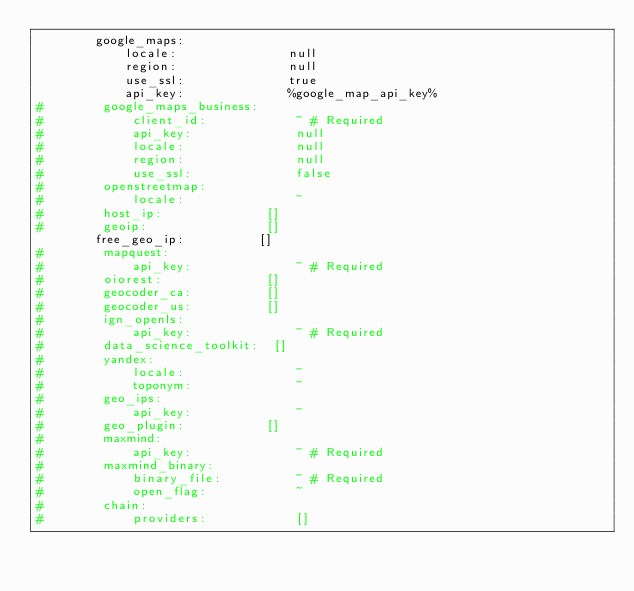<code> <loc_0><loc_0><loc_500><loc_500><_YAML_>        google_maps:
            locale:               null
            region:               null
            use_ssl:              true
            api_key:              %google_map_api_key%
#        google_maps_business:
#            client_id:            ~ # Required
#            api_key:              null
#            locale:               null
#            region:               null
#            use_ssl:              false
#        openstreetmap:
#            locale:               ~
#        host_ip:              []
#        geoip:                []
        free_geo_ip:          []
#        mapquest:
#            api_key:              ~ # Required
#        oiorest:              []
#        geocoder_ca:          []
#        geocoder_us:          []
#        ign_openls:
#            api_key:              ~ # Required
#        data_science_toolkit:  []
#        yandex:
#            locale:               ~
#            toponym:              ~
#        geo_ips:
#            api_key:              ~
#        geo_plugin:           []
#        maxmind:
#            api_key:              ~ # Required
#        maxmind_binary:
#            binary_file:          ~ # Required
#            open_flag:            ~
#        chain:
#            providers:            []
        </code> 